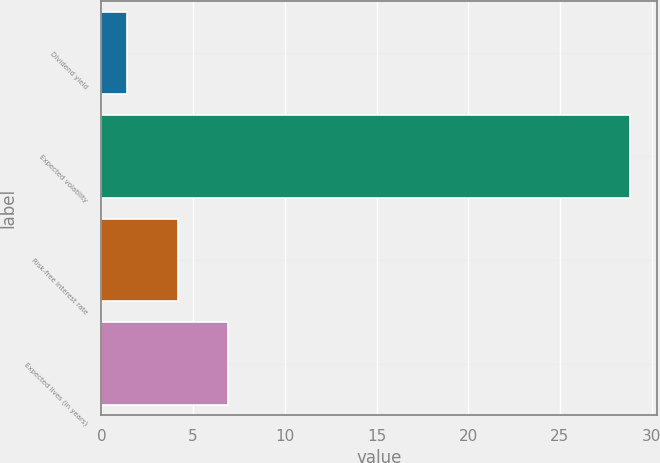Convert chart. <chart><loc_0><loc_0><loc_500><loc_500><bar_chart><fcel>Dividend yield<fcel>Expected volatility<fcel>Risk-free interest rate<fcel>Expected lives (in years)<nl><fcel>1.41<fcel>28.85<fcel>4.15<fcel>6.89<nl></chart> 